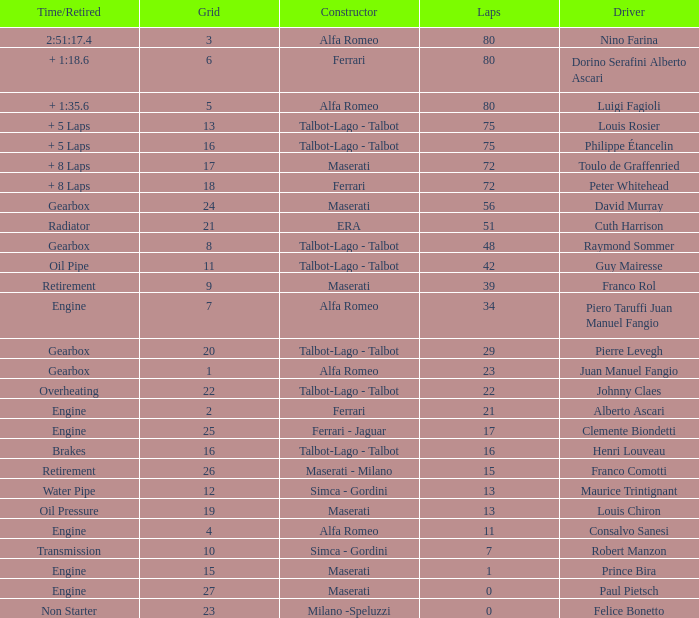When grid is less than 7, laps are greater than 17, and time/retired is + 1:35.6, who is the constructor? Alfa Romeo. 